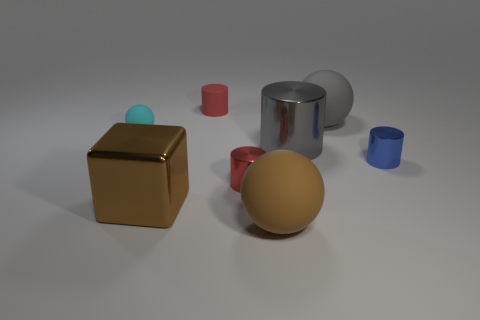Is there any other thing that has the same material as the gray cylinder?
Your response must be concise. Yes. Do the brown metallic object and the small thing to the left of the large brown shiny object have the same shape?
Offer a very short reply. No. How many yellow objects are matte things or tiny rubber things?
Provide a short and direct response. 0. What number of objects are both in front of the tiny blue cylinder and left of the big brown matte sphere?
Your answer should be compact. 2. The big thing that is behind the large shiny thing to the right of the large brown metal object that is in front of the red matte cylinder is made of what material?
Provide a succinct answer. Rubber. How many gray balls have the same material as the small cyan ball?
Your answer should be very brief. 1. There is a large rubber object that is the same color as the big cube; what is its shape?
Offer a very short reply. Sphere. There is a red matte thing that is the same size as the blue object; what shape is it?
Your response must be concise. Cylinder. There is a object that is the same color as the tiny rubber cylinder; what is it made of?
Offer a very short reply. Metal. Are there any cyan matte things in front of the tiny cyan thing?
Provide a succinct answer. No. 